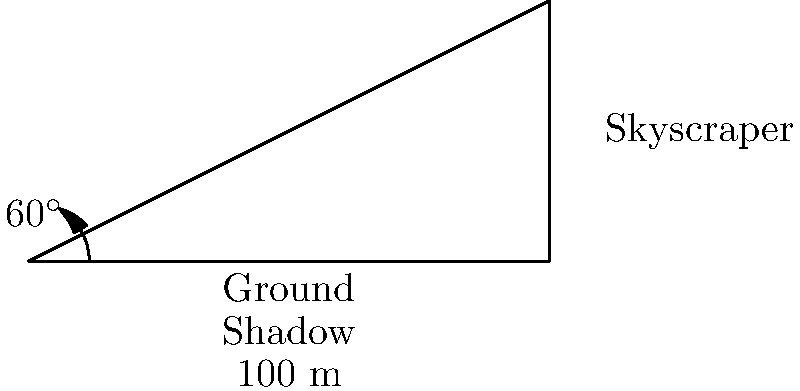As you gaze out of your apartment window, you notice a skyscraper casting a shadow on the bustling city street below. The shadow stretches 100 meters along the ground, and the angle of elevation from the end of the shadow to the top of the skyscraper is $60^\circ$. Using this information, calculate the height of the skyscraper to the nearest meter. Let's approach this step-by-step:

1) In this scenario, we have a right-angled triangle. The shadow forms the base, the skyscraper forms the height, and the line of sight from the end of the shadow to the top of the skyscraper forms the hypotenuse.

2) We know:
   - The length of the shadow (base) is 100 meters
   - The angle of elevation is $60^\circ$

3) To find the height, we need to use the tangent function. The tangent of an angle in a right triangle is the ratio of the opposite side to the adjacent side.

4) In this case:
   $\tan 60^\circ = \frac{\text{height}}{\text{shadow length}}$

5) We can write this as an equation:
   $\tan 60^\circ = \frac{h}{100}$, where $h$ is the height we're looking for.

6) To solve for $h$, we multiply both sides by 100:
   $h = 100 \tan 60^\circ$

7) We know that $\tan 60^\circ = \sqrt{3} \approx 1.732$

8) Therefore:
   $h = 100 * 1.732 = 173.2$ meters

9) Rounding to the nearest meter, we get 173 meters.
Answer: 173 meters 